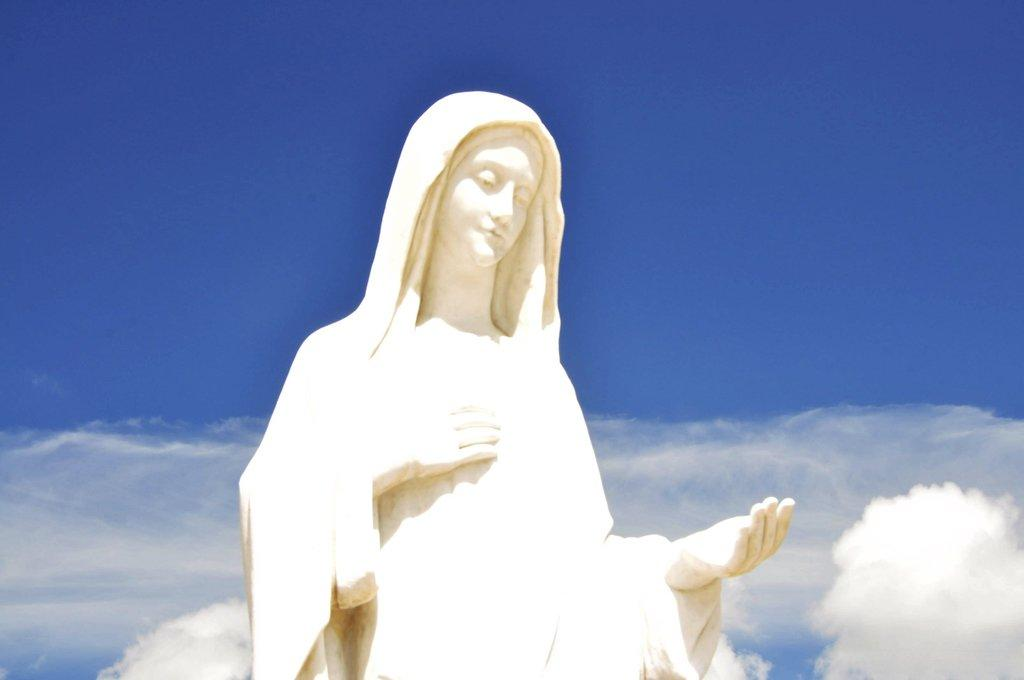What is the main subject in the foreground of the image? There is a sculpture in the foreground of the image. What can be seen in the background of the image? The sky is visible in the background of the image. Are there any additional features in the background? Yes, clouds are present in the background of the image. What type of jelly can be seen dripping from the sculpture in the image? There is no jelly present in the image, and therefore no such activity can be observed. 